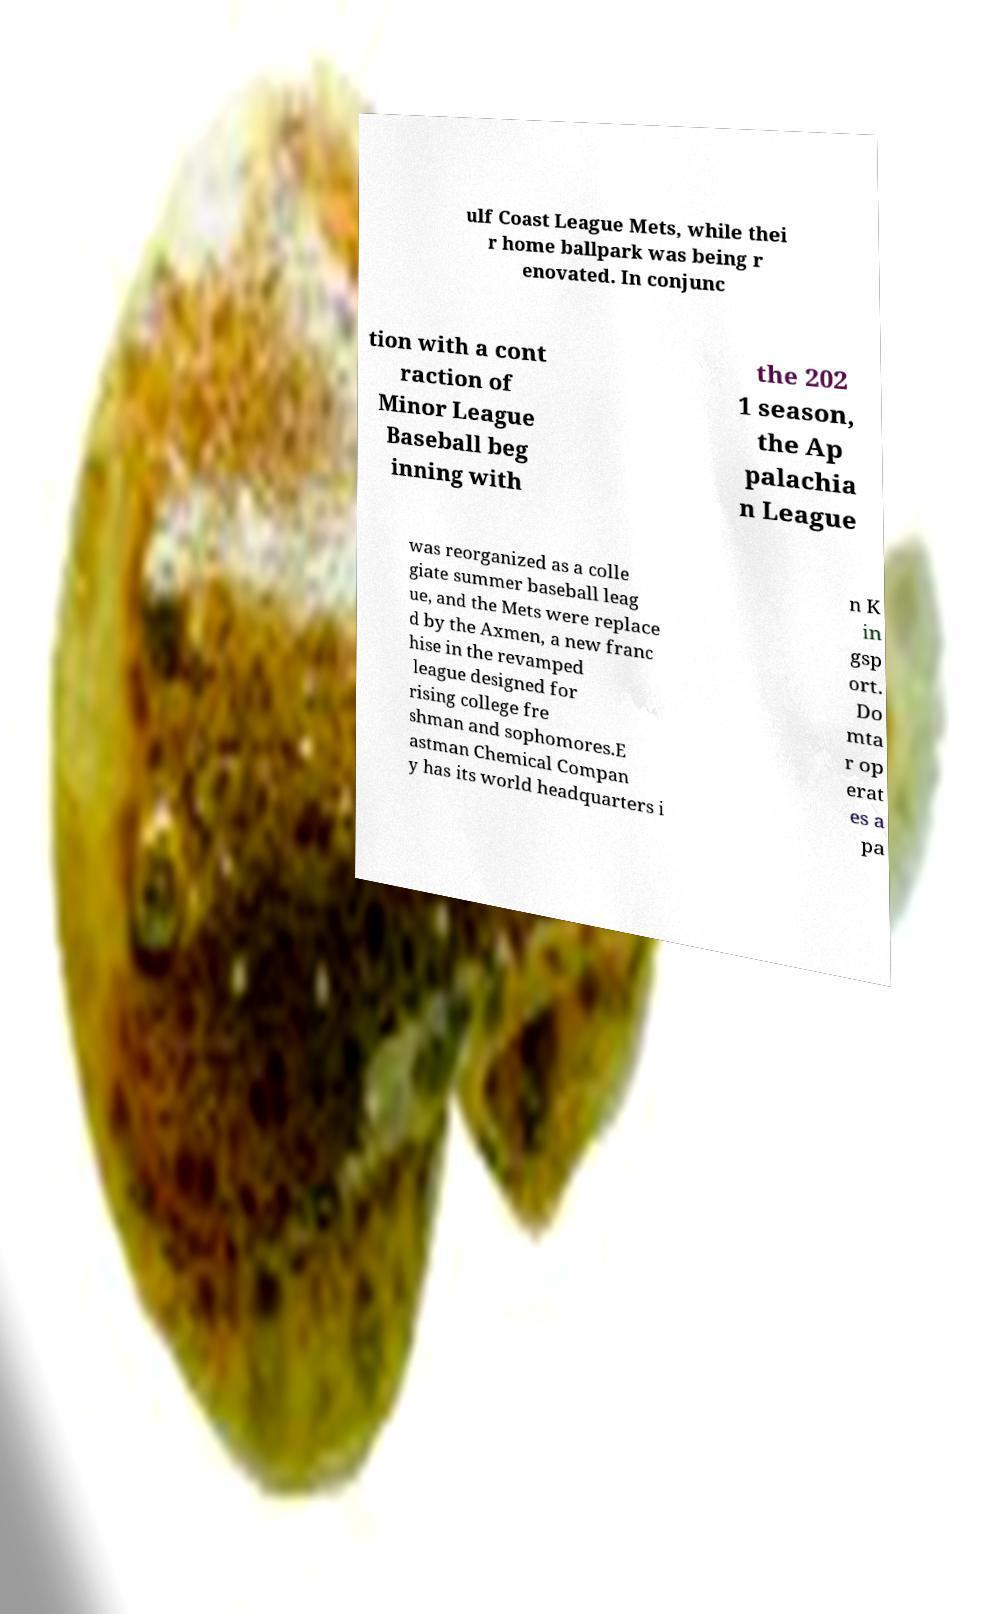I need the written content from this picture converted into text. Can you do that? ulf Coast League Mets, while thei r home ballpark was being r enovated. In conjunc tion with a cont raction of Minor League Baseball beg inning with the 202 1 season, the Ap palachia n League was reorganized as a colle giate summer baseball leag ue, and the Mets were replace d by the Axmen, a new franc hise in the revamped league designed for rising college fre shman and sophomores.E astman Chemical Compan y has its world headquarters i n K in gsp ort. Do mta r op erat es a pa 